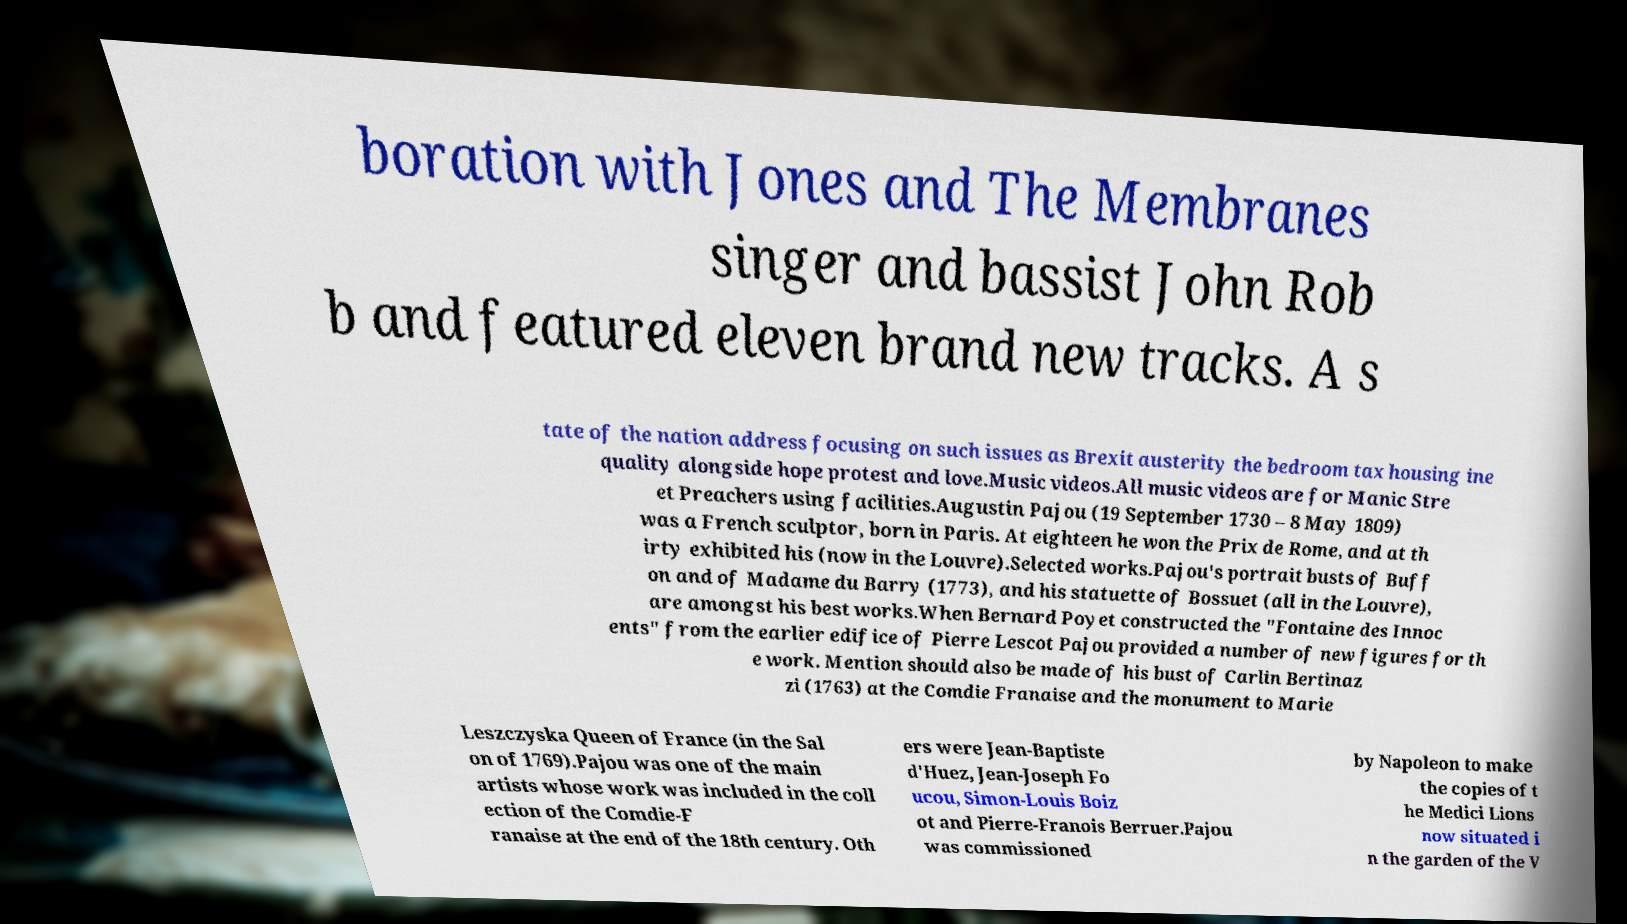For documentation purposes, I need the text within this image transcribed. Could you provide that? boration with Jones and The Membranes singer and bassist John Rob b and featured eleven brand new tracks. A s tate of the nation address focusing on such issues as Brexit austerity the bedroom tax housing ine quality alongside hope protest and love.Music videos.All music videos are for Manic Stre et Preachers using facilities.Augustin Pajou (19 September 1730 – 8 May 1809) was a French sculptor, born in Paris. At eighteen he won the Prix de Rome, and at th irty exhibited his (now in the Louvre).Selected works.Pajou's portrait busts of Buff on and of Madame du Barry (1773), and his statuette of Bossuet (all in the Louvre), are amongst his best works.When Bernard Poyet constructed the "Fontaine des Innoc ents" from the earlier edifice of Pierre Lescot Pajou provided a number of new figures for th e work. Mention should also be made of his bust of Carlin Bertinaz zi (1763) at the Comdie Franaise and the monument to Marie Leszczyska Queen of France (in the Sal on of 1769).Pajou was one of the main artists whose work was included in the coll ection of the Comdie-F ranaise at the end of the 18th century. Oth ers were Jean-Baptiste d'Huez, Jean-Joseph Fo ucou, Simon-Louis Boiz ot and Pierre-Franois Berruer.Pajou was commissioned by Napoleon to make the copies of t he Medici Lions now situated i n the garden of the V 